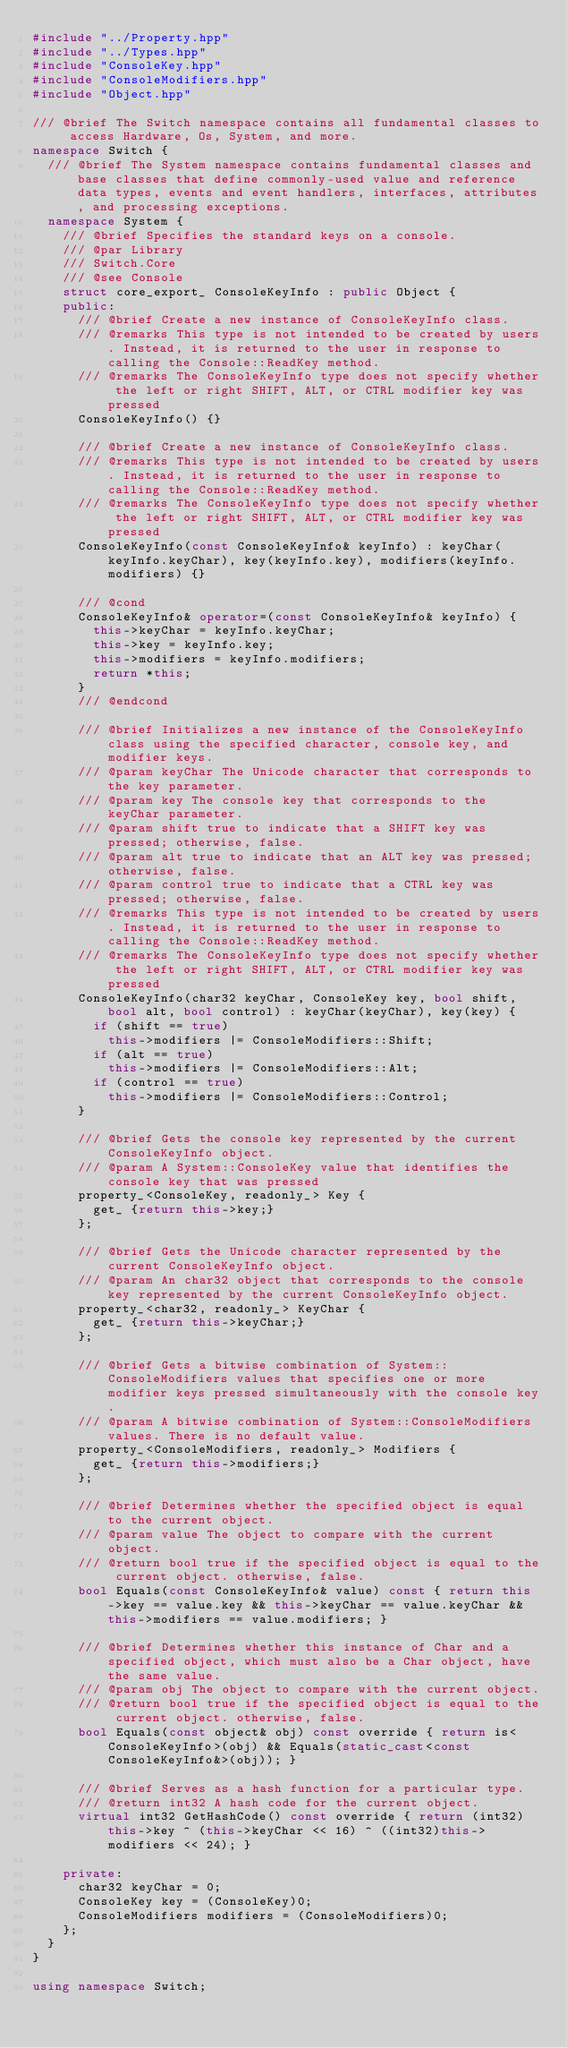<code> <loc_0><loc_0><loc_500><loc_500><_C++_>#include "../Property.hpp"
#include "../Types.hpp"
#include "ConsoleKey.hpp"
#include "ConsoleModifiers.hpp"
#include "Object.hpp"

/// @brief The Switch namespace contains all fundamental classes to access Hardware, Os, System, and more.
namespace Switch {
  /// @brief The System namespace contains fundamental classes and base classes that define commonly-used value and reference data types, events and event handlers, interfaces, attributes, and processing exceptions.
  namespace System {
    /// @brief Specifies the standard keys on a console.
    /// @par Library
    /// Switch.Core
    /// @see Console
    struct core_export_ ConsoleKeyInfo : public Object {
    public:
      /// @brief Create a new instance of ConsoleKeyInfo class.
      /// @remarks This type is not intended to be created by users. Instead, it is returned to the user in response to calling the Console::ReadKey method.
      /// @remarks The ConsoleKeyInfo type does not specify whether the left or right SHIFT, ALT, or CTRL modifier key was pressed
      ConsoleKeyInfo() {}

      /// @brief Create a new instance of ConsoleKeyInfo class.
      /// @remarks This type is not intended to be created by users. Instead, it is returned to the user in response to calling the Console::ReadKey method.
      /// @remarks The ConsoleKeyInfo type does not specify whether the left or right SHIFT, ALT, or CTRL modifier key was pressed
      ConsoleKeyInfo(const ConsoleKeyInfo& keyInfo) : keyChar(keyInfo.keyChar), key(keyInfo.key), modifiers(keyInfo.modifiers) {}

      /// @cond
      ConsoleKeyInfo& operator=(const ConsoleKeyInfo& keyInfo) {
        this->keyChar = keyInfo.keyChar;
        this->key = keyInfo.key;
        this->modifiers = keyInfo.modifiers;
        return *this;
      }
      /// @endcond

      /// @brief Initializes a new instance of the ConsoleKeyInfo class using the specified character, console key, and modifier keys.
      /// @param keyChar The Unicode character that corresponds to the key parameter.
      /// @param key The console key that corresponds to the keyChar parameter.
      /// @param shift true to indicate that a SHIFT key was pressed; otherwise, false.
      /// @param alt true to indicate that an ALT key was pressed; otherwise, false.
      /// @param control true to indicate that a CTRL key was pressed; otherwise, false.
      /// @remarks This type is not intended to be created by users. Instead, it is returned to the user in response to calling the Console::ReadKey method.
      /// @remarks The ConsoleKeyInfo type does not specify whether the left or right SHIFT, ALT, or CTRL modifier key was pressed
      ConsoleKeyInfo(char32 keyChar, ConsoleKey key, bool shift, bool alt, bool control) : keyChar(keyChar), key(key) {
        if (shift == true)
          this->modifiers |= ConsoleModifiers::Shift;
        if (alt == true)
          this->modifiers |= ConsoleModifiers::Alt;
        if (control == true)
          this->modifiers |= ConsoleModifiers::Control;
      }

      /// @brief Gets the console key represented by the current ConsoleKeyInfo object.
      /// @param A System::ConsoleKey value that identifies the console key that was pressed
      property_<ConsoleKey, readonly_> Key {
        get_ {return this->key;}
      };

      /// @brief Gets the Unicode character represented by the current ConsoleKeyInfo object.
      /// @param An char32 object that corresponds to the console key represented by the current ConsoleKeyInfo object.
      property_<char32, readonly_> KeyChar {
        get_ {return this->keyChar;}
      };

      /// @brief Gets a bitwise combination of System::ConsoleModifiers values that specifies one or more modifier keys pressed simultaneously with the console key.
      /// @param A bitwise combination of System::ConsoleModifiers values. There is no default value.
      property_<ConsoleModifiers, readonly_> Modifiers {
        get_ {return this->modifiers;}
      };

      /// @brief Determines whether the specified object is equal to the current object.
      /// @param value The object to compare with the current object.
      /// @return bool true if the specified object is equal to the current object. otherwise, false.
      bool Equals(const ConsoleKeyInfo& value) const { return this->key == value.key && this->keyChar == value.keyChar && this->modifiers == value.modifiers; }

      /// @brief Determines whether this instance of Char and a specified object, which must also be a Char object, have the same value.
      /// @param obj The object to compare with the current object.
      /// @return bool true if the specified object is equal to the current object. otherwise, false.
      bool Equals(const object& obj) const override { return is<ConsoleKeyInfo>(obj) && Equals(static_cast<const ConsoleKeyInfo&>(obj)); }

      /// @brief Serves as a hash function for a particular type.
      /// @return int32 A hash code for the current object.
      virtual int32 GetHashCode() const override { return (int32)this->key ^ (this->keyChar << 16) ^ ((int32)this->modifiers << 24); }

    private:
      char32 keyChar = 0;
      ConsoleKey key = (ConsoleKey)0;
      ConsoleModifiers modifiers = (ConsoleModifiers)0;
    };
  }
}

using namespace Switch;
</code> 